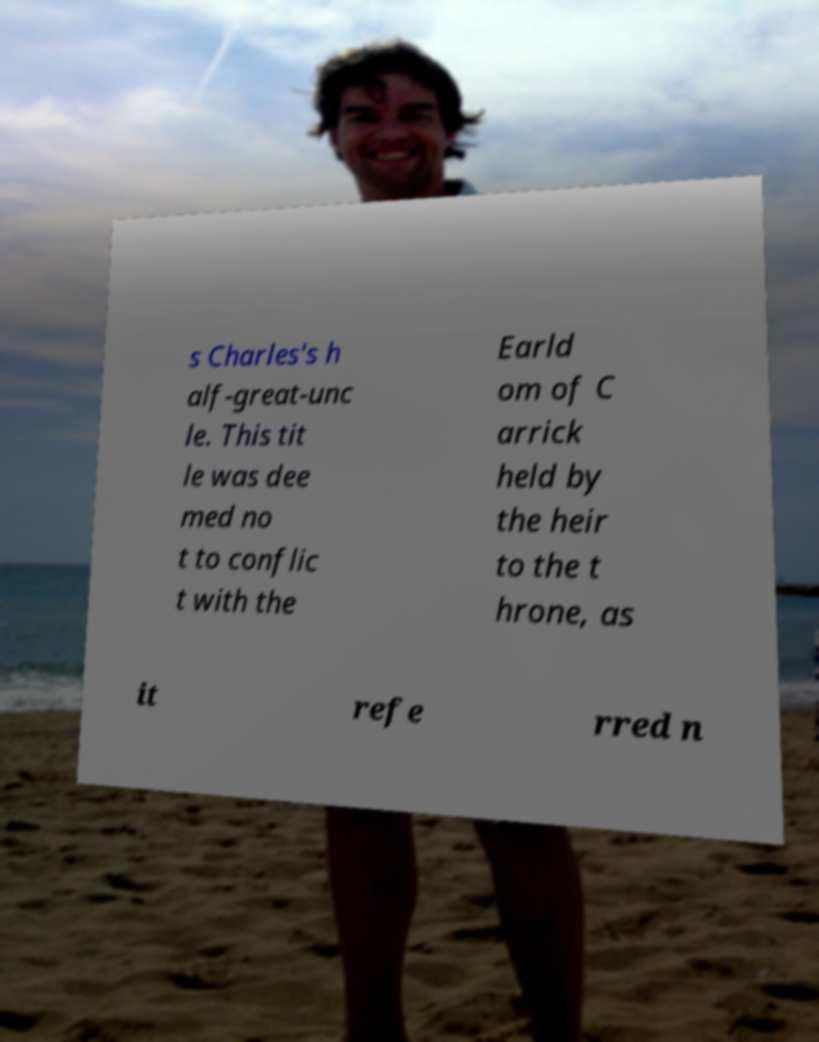Could you extract and type out the text from this image? s Charles's h alf-great-unc le. This tit le was dee med no t to conflic t with the Earld om of C arrick held by the heir to the t hrone, as it refe rred n 